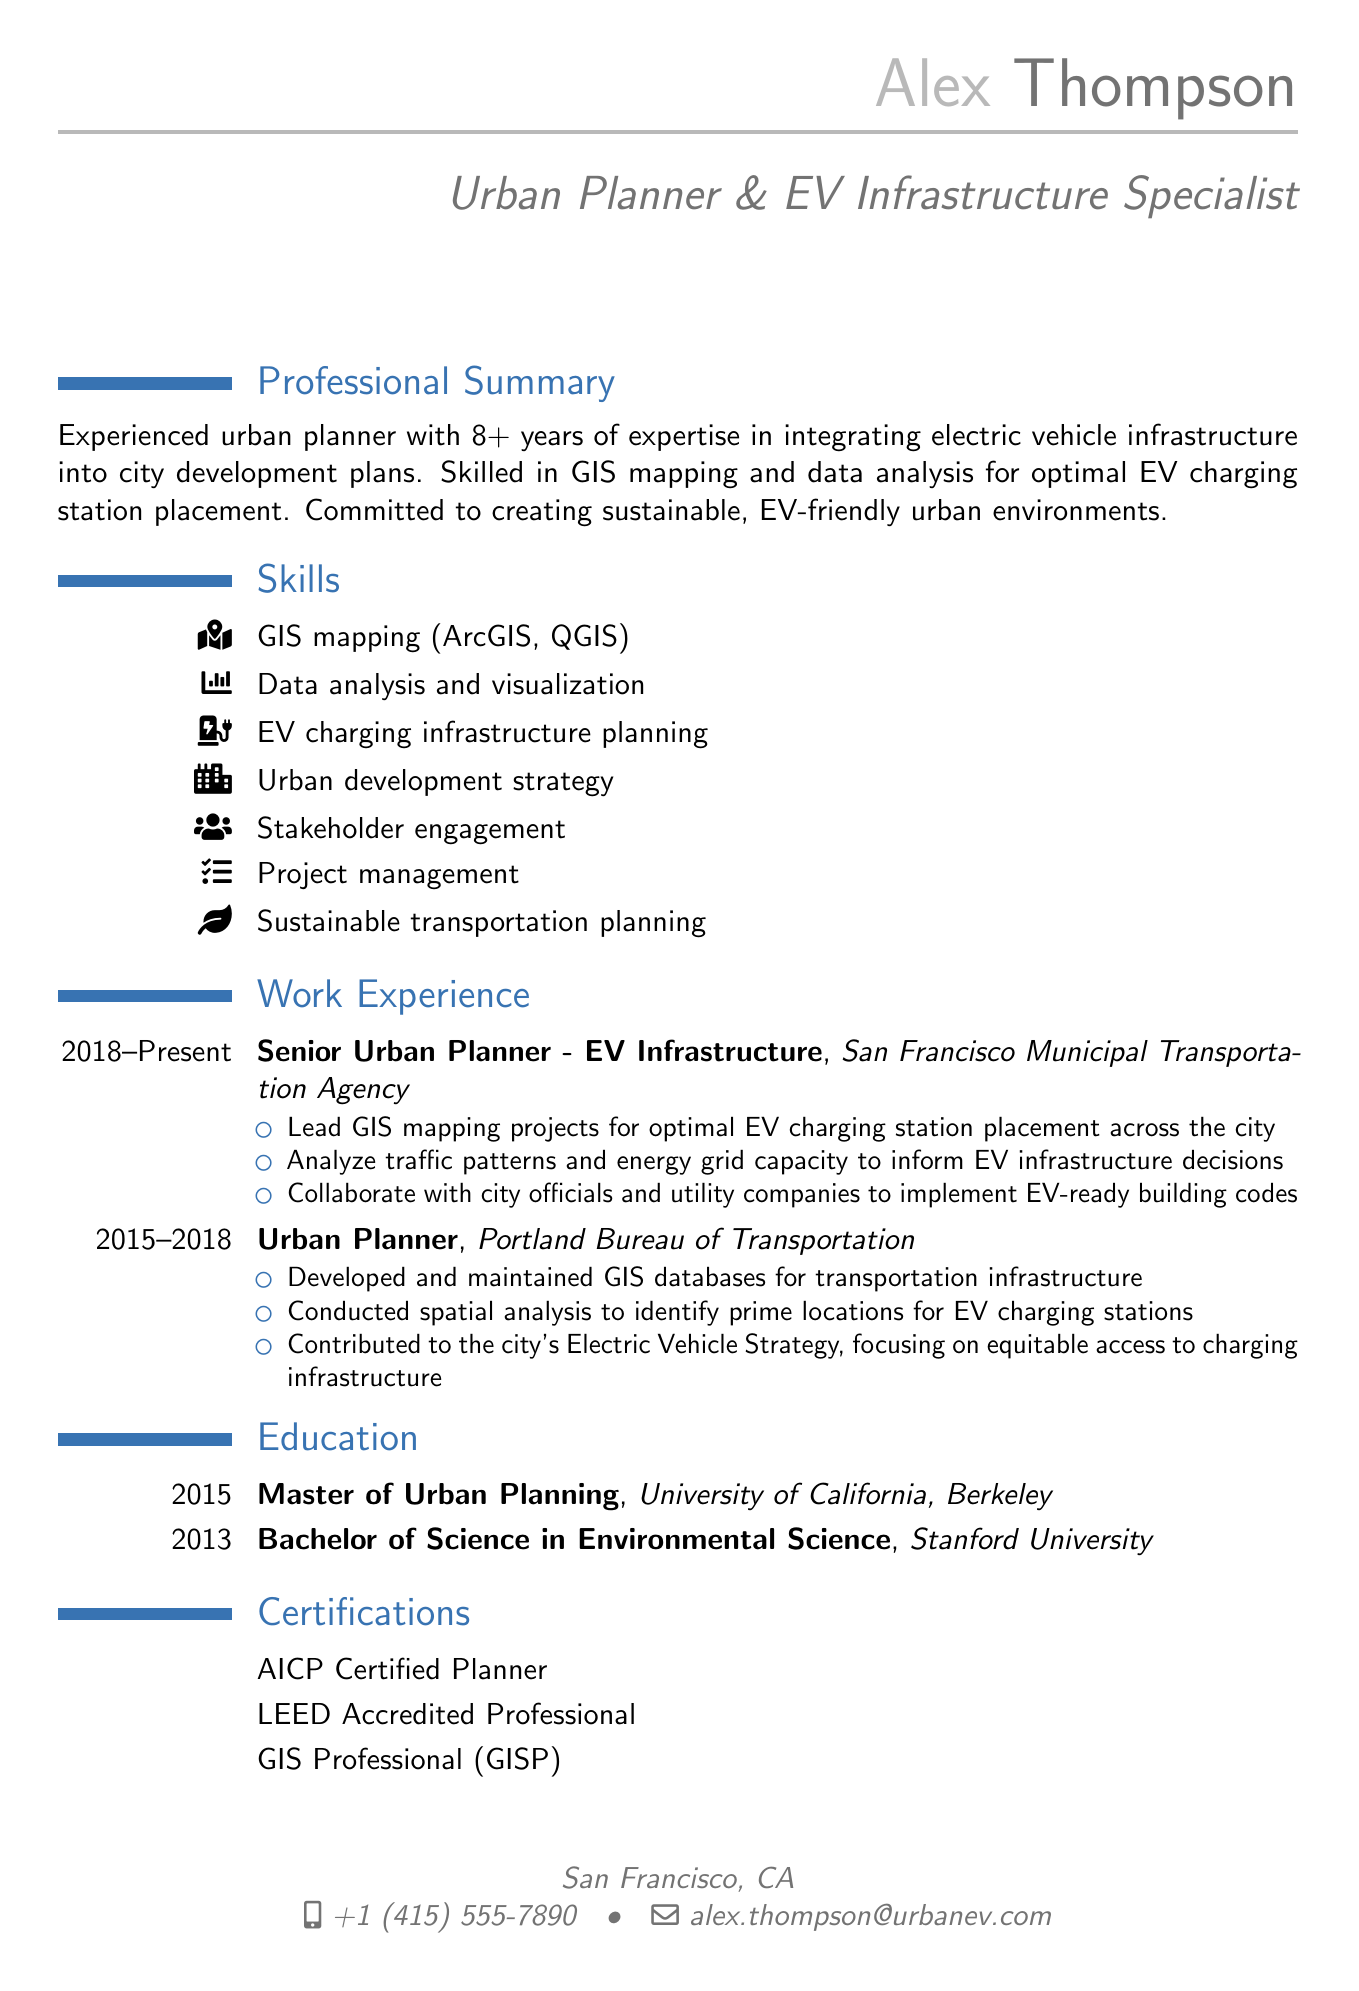what is the name of the individual? The name of the individual is listed at the beginning of the document.
Answer: Alex Thompson what is the title listed in the CV? The title is described in the personal information section of the document.
Answer: Urban Planner & EV Infrastructure Specialist how many years of experience does the individual have? The professional summary states the number of years of experience clearly.
Answer: 8+ which company does Alex Thompson currently work for? The work experience section indicates the current employer.
Answer: San Francisco Municipal Transportation Agency what degree did Alex Thompson earn in 2015? The education section lists degrees and their years.
Answer: Master of Urban Planning what certification related to urban planning does Alex hold? The certifications section lists the specific qualifications.
Answer: AICP Certified Planner which project resulted in a 30% increase in public charging stations? The key projects section provides specific project outcomes.
Answer: SF EV Readiness Plan what was Alex's role in the Portland EV Equity Initiative? The projects section describes contributions to specific initiatives.
Answer: Utilized GIS mapping why is GIS mapping important in Alex's work? Reasoning requires connecting the role of GIS mapping with EV infrastructure planning.
Answer: It helps identify optimal locations for charging stations 